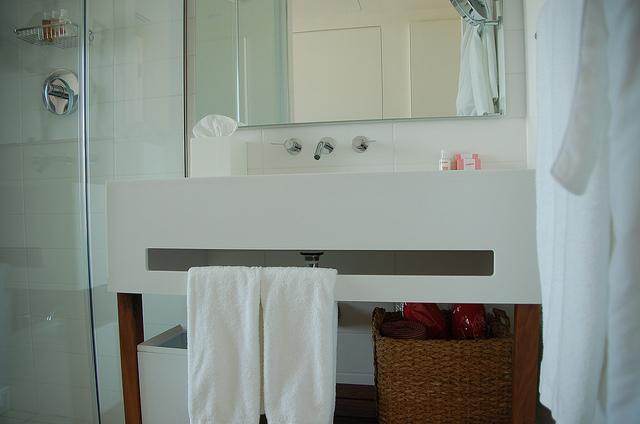How many towels and washcloths can be seen on the shelf?
Answer briefly. 2. What are the red objects in the basket?
Concise answer only. Hair dryer. Can you get water in this room?
Write a very short answer. Yes. How  many mirrors are there?
Write a very short answer. 1. What room is this?
Keep it brief. Bathroom. 